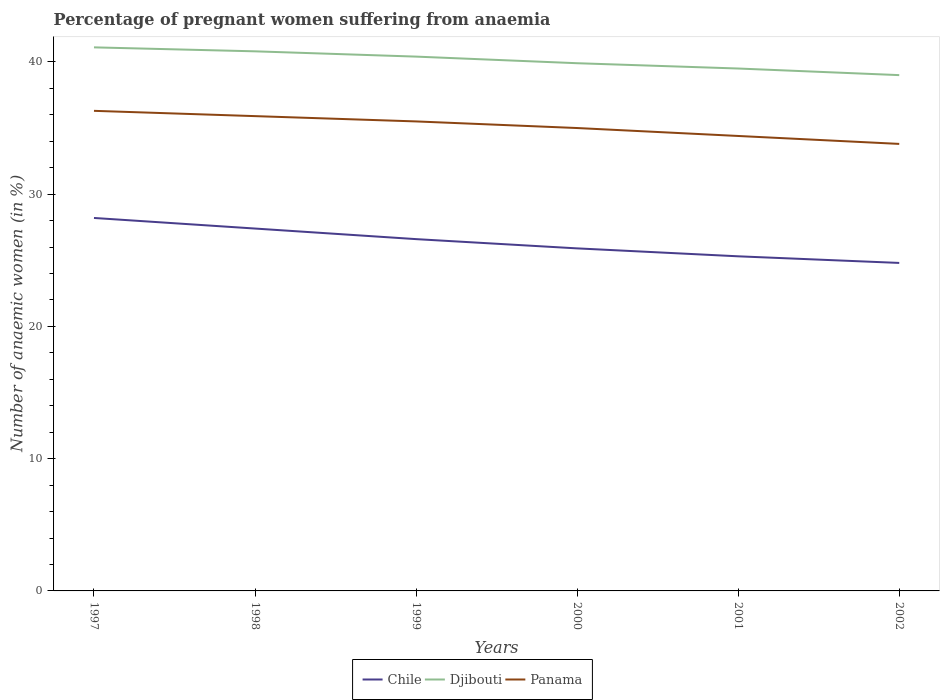How many different coloured lines are there?
Provide a short and direct response. 3. What is the difference between the highest and the second highest number of anaemic women in Djibouti?
Give a very brief answer. 2.1. How many lines are there?
Your answer should be very brief. 3. What is the difference between two consecutive major ticks on the Y-axis?
Provide a succinct answer. 10. Are the values on the major ticks of Y-axis written in scientific E-notation?
Your answer should be very brief. No. Does the graph contain any zero values?
Make the answer very short. No. Does the graph contain grids?
Offer a very short reply. No. Where does the legend appear in the graph?
Keep it short and to the point. Bottom center. How many legend labels are there?
Your response must be concise. 3. How are the legend labels stacked?
Give a very brief answer. Horizontal. What is the title of the graph?
Offer a terse response. Percentage of pregnant women suffering from anaemia. What is the label or title of the Y-axis?
Keep it short and to the point. Number of anaemic women (in %). What is the Number of anaemic women (in %) of Chile in 1997?
Your answer should be very brief. 28.2. What is the Number of anaemic women (in %) in Djibouti in 1997?
Your answer should be very brief. 41.1. What is the Number of anaemic women (in %) of Panama in 1997?
Keep it short and to the point. 36.3. What is the Number of anaemic women (in %) of Chile in 1998?
Your response must be concise. 27.4. What is the Number of anaemic women (in %) in Djibouti in 1998?
Provide a short and direct response. 40.8. What is the Number of anaemic women (in %) of Panama in 1998?
Make the answer very short. 35.9. What is the Number of anaemic women (in %) of Chile in 1999?
Your answer should be compact. 26.6. What is the Number of anaemic women (in %) of Djibouti in 1999?
Offer a terse response. 40.4. What is the Number of anaemic women (in %) of Panama in 1999?
Your answer should be compact. 35.5. What is the Number of anaemic women (in %) in Chile in 2000?
Your answer should be very brief. 25.9. What is the Number of anaemic women (in %) of Djibouti in 2000?
Offer a terse response. 39.9. What is the Number of anaemic women (in %) of Chile in 2001?
Your answer should be very brief. 25.3. What is the Number of anaemic women (in %) of Djibouti in 2001?
Make the answer very short. 39.5. What is the Number of anaemic women (in %) in Panama in 2001?
Give a very brief answer. 34.4. What is the Number of anaemic women (in %) in Chile in 2002?
Give a very brief answer. 24.8. What is the Number of anaemic women (in %) of Panama in 2002?
Your response must be concise. 33.8. Across all years, what is the maximum Number of anaemic women (in %) of Chile?
Provide a succinct answer. 28.2. Across all years, what is the maximum Number of anaemic women (in %) of Djibouti?
Your answer should be compact. 41.1. Across all years, what is the maximum Number of anaemic women (in %) of Panama?
Provide a succinct answer. 36.3. Across all years, what is the minimum Number of anaemic women (in %) of Chile?
Make the answer very short. 24.8. Across all years, what is the minimum Number of anaemic women (in %) in Panama?
Provide a succinct answer. 33.8. What is the total Number of anaemic women (in %) of Chile in the graph?
Provide a succinct answer. 158.2. What is the total Number of anaemic women (in %) in Djibouti in the graph?
Provide a succinct answer. 240.7. What is the total Number of anaemic women (in %) in Panama in the graph?
Provide a succinct answer. 210.9. What is the difference between the Number of anaemic women (in %) of Djibouti in 1997 and that in 1998?
Give a very brief answer. 0.3. What is the difference between the Number of anaemic women (in %) of Chile in 1997 and that in 1999?
Provide a succinct answer. 1.6. What is the difference between the Number of anaemic women (in %) of Djibouti in 1997 and that in 1999?
Ensure brevity in your answer.  0.7. What is the difference between the Number of anaemic women (in %) in Djibouti in 1997 and that in 2000?
Keep it short and to the point. 1.2. What is the difference between the Number of anaemic women (in %) of Panama in 1997 and that in 2000?
Give a very brief answer. 1.3. What is the difference between the Number of anaemic women (in %) of Chile in 1997 and that in 2001?
Offer a terse response. 2.9. What is the difference between the Number of anaemic women (in %) in Chile in 1997 and that in 2002?
Provide a short and direct response. 3.4. What is the difference between the Number of anaemic women (in %) of Panama in 1997 and that in 2002?
Provide a succinct answer. 2.5. What is the difference between the Number of anaemic women (in %) in Chile in 1998 and that in 1999?
Your response must be concise. 0.8. What is the difference between the Number of anaemic women (in %) in Djibouti in 1998 and that in 1999?
Offer a terse response. 0.4. What is the difference between the Number of anaemic women (in %) in Panama in 1998 and that in 1999?
Offer a terse response. 0.4. What is the difference between the Number of anaemic women (in %) in Djibouti in 1998 and that in 2000?
Ensure brevity in your answer.  0.9. What is the difference between the Number of anaemic women (in %) of Panama in 1998 and that in 2000?
Offer a very short reply. 0.9. What is the difference between the Number of anaemic women (in %) of Djibouti in 1998 and that in 2001?
Ensure brevity in your answer.  1.3. What is the difference between the Number of anaemic women (in %) of Chile in 1998 and that in 2002?
Offer a terse response. 2.6. What is the difference between the Number of anaemic women (in %) of Chile in 1999 and that in 2000?
Offer a terse response. 0.7. What is the difference between the Number of anaemic women (in %) of Djibouti in 1999 and that in 2000?
Provide a short and direct response. 0.5. What is the difference between the Number of anaemic women (in %) of Panama in 1999 and that in 2000?
Make the answer very short. 0.5. What is the difference between the Number of anaemic women (in %) in Djibouti in 1999 and that in 2001?
Offer a terse response. 0.9. What is the difference between the Number of anaemic women (in %) of Djibouti in 1999 and that in 2002?
Your answer should be very brief. 1.4. What is the difference between the Number of anaemic women (in %) of Panama in 1999 and that in 2002?
Keep it short and to the point. 1.7. What is the difference between the Number of anaemic women (in %) of Djibouti in 2000 and that in 2001?
Give a very brief answer. 0.4. What is the difference between the Number of anaemic women (in %) in Panama in 2000 and that in 2001?
Your answer should be very brief. 0.6. What is the difference between the Number of anaemic women (in %) in Panama in 2000 and that in 2002?
Give a very brief answer. 1.2. What is the difference between the Number of anaemic women (in %) in Chile in 2001 and that in 2002?
Provide a short and direct response. 0.5. What is the difference between the Number of anaemic women (in %) in Panama in 2001 and that in 2002?
Your answer should be very brief. 0.6. What is the difference between the Number of anaemic women (in %) of Chile in 1997 and the Number of anaemic women (in %) of Djibouti in 1998?
Keep it short and to the point. -12.6. What is the difference between the Number of anaemic women (in %) of Chile in 1997 and the Number of anaemic women (in %) of Djibouti in 2000?
Your response must be concise. -11.7. What is the difference between the Number of anaemic women (in %) of Chile in 1997 and the Number of anaemic women (in %) of Djibouti in 2001?
Provide a succinct answer. -11.3. What is the difference between the Number of anaemic women (in %) in Chile in 1997 and the Number of anaemic women (in %) in Panama in 2001?
Make the answer very short. -6.2. What is the difference between the Number of anaemic women (in %) of Chile in 1997 and the Number of anaemic women (in %) of Panama in 2002?
Ensure brevity in your answer.  -5.6. What is the difference between the Number of anaemic women (in %) of Chile in 1998 and the Number of anaemic women (in %) of Panama in 1999?
Give a very brief answer. -8.1. What is the difference between the Number of anaemic women (in %) in Chile in 1998 and the Number of anaemic women (in %) in Djibouti in 2000?
Your answer should be compact. -12.5. What is the difference between the Number of anaemic women (in %) in Chile in 1998 and the Number of anaemic women (in %) in Panama in 2000?
Your response must be concise. -7.6. What is the difference between the Number of anaemic women (in %) in Chile in 1998 and the Number of anaemic women (in %) in Panama in 2001?
Your answer should be very brief. -7. What is the difference between the Number of anaemic women (in %) of Djibouti in 1998 and the Number of anaemic women (in %) of Panama in 2001?
Provide a short and direct response. 6.4. What is the difference between the Number of anaemic women (in %) of Chile in 1999 and the Number of anaemic women (in %) of Djibouti in 2000?
Provide a short and direct response. -13.3. What is the difference between the Number of anaemic women (in %) in Chile in 1999 and the Number of anaemic women (in %) in Panama in 2000?
Your response must be concise. -8.4. What is the difference between the Number of anaemic women (in %) in Chile in 1999 and the Number of anaemic women (in %) in Djibouti in 2001?
Provide a short and direct response. -12.9. What is the difference between the Number of anaemic women (in %) of Chile in 1999 and the Number of anaemic women (in %) of Panama in 2001?
Ensure brevity in your answer.  -7.8. What is the difference between the Number of anaemic women (in %) of Djibouti in 1999 and the Number of anaemic women (in %) of Panama in 2001?
Offer a terse response. 6. What is the difference between the Number of anaemic women (in %) in Chile in 1999 and the Number of anaemic women (in %) in Djibouti in 2002?
Keep it short and to the point. -12.4. What is the difference between the Number of anaemic women (in %) in Chile in 1999 and the Number of anaemic women (in %) in Panama in 2002?
Offer a very short reply. -7.2. What is the difference between the Number of anaemic women (in %) in Djibouti in 1999 and the Number of anaemic women (in %) in Panama in 2002?
Provide a succinct answer. 6.6. What is the difference between the Number of anaemic women (in %) of Chile in 2000 and the Number of anaemic women (in %) of Djibouti in 2001?
Your response must be concise. -13.6. What is the difference between the Number of anaemic women (in %) in Chile in 2000 and the Number of anaemic women (in %) in Panama in 2001?
Ensure brevity in your answer.  -8.5. What is the difference between the Number of anaemic women (in %) in Chile in 2000 and the Number of anaemic women (in %) in Djibouti in 2002?
Provide a short and direct response. -13.1. What is the difference between the Number of anaemic women (in %) in Chile in 2000 and the Number of anaemic women (in %) in Panama in 2002?
Ensure brevity in your answer.  -7.9. What is the difference between the Number of anaemic women (in %) of Chile in 2001 and the Number of anaemic women (in %) of Djibouti in 2002?
Provide a succinct answer. -13.7. What is the average Number of anaemic women (in %) in Chile per year?
Your response must be concise. 26.37. What is the average Number of anaemic women (in %) in Djibouti per year?
Keep it short and to the point. 40.12. What is the average Number of anaemic women (in %) in Panama per year?
Provide a succinct answer. 35.15. In the year 1998, what is the difference between the Number of anaemic women (in %) in Chile and Number of anaemic women (in %) in Djibouti?
Ensure brevity in your answer.  -13.4. In the year 1998, what is the difference between the Number of anaemic women (in %) of Chile and Number of anaemic women (in %) of Panama?
Offer a terse response. -8.5. In the year 1998, what is the difference between the Number of anaemic women (in %) in Djibouti and Number of anaemic women (in %) in Panama?
Your answer should be very brief. 4.9. In the year 1999, what is the difference between the Number of anaemic women (in %) of Chile and Number of anaemic women (in %) of Djibouti?
Provide a short and direct response. -13.8. In the year 1999, what is the difference between the Number of anaemic women (in %) in Chile and Number of anaemic women (in %) in Panama?
Keep it short and to the point. -8.9. In the year 2001, what is the difference between the Number of anaemic women (in %) in Chile and Number of anaemic women (in %) in Djibouti?
Offer a very short reply. -14.2. In the year 2001, what is the difference between the Number of anaemic women (in %) of Chile and Number of anaemic women (in %) of Panama?
Your response must be concise. -9.1. In the year 2001, what is the difference between the Number of anaemic women (in %) in Djibouti and Number of anaemic women (in %) in Panama?
Offer a terse response. 5.1. In the year 2002, what is the difference between the Number of anaemic women (in %) in Chile and Number of anaemic women (in %) in Djibouti?
Offer a terse response. -14.2. In the year 2002, what is the difference between the Number of anaemic women (in %) in Djibouti and Number of anaemic women (in %) in Panama?
Offer a very short reply. 5.2. What is the ratio of the Number of anaemic women (in %) in Chile in 1997 to that in 1998?
Your answer should be very brief. 1.03. What is the ratio of the Number of anaemic women (in %) in Djibouti in 1997 to that in 1998?
Your response must be concise. 1.01. What is the ratio of the Number of anaemic women (in %) of Panama in 1997 to that in 1998?
Offer a very short reply. 1.01. What is the ratio of the Number of anaemic women (in %) in Chile in 1997 to that in 1999?
Give a very brief answer. 1.06. What is the ratio of the Number of anaemic women (in %) in Djibouti in 1997 to that in 1999?
Keep it short and to the point. 1.02. What is the ratio of the Number of anaemic women (in %) in Panama in 1997 to that in 1999?
Provide a succinct answer. 1.02. What is the ratio of the Number of anaemic women (in %) of Chile in 1997 to that in 2000?
Your answer should be compact. 1.09. What is the ratio of the Number of anaemic women (in %) in Djibouti in 1997 to that in 2000?
Make the answer very short. 1.03. What is the ratio of the Number of anaemic women (in %) of Panama in 1997 to that in 2000?
Your answer should be compact. 1.04. What is the ratio of the Number of anaemic women (in %) of Chile in 1997 to that in 2001?
Offer a terse response. 1.11. What is the ratio of the Number of anaemic women (in %) in Djibouti in 1997 to that in 2001?
Give a very brief answer. 1.04. What is the ratio of the Number of anaemic women (in %) of Panama in 1997 to that in 2001?
Offer a terse response. 1.06. What is the ratio of the Number of anaemic women (in %) in Chile in 1997 to that in 2002?
Offer a very short reply. 1.14. What is the ratio of the Number of anaemic women (in %) of Djibouti in 1997 to that in 2002?
Your response must be concise. 1.05. What is the ratio of the Number of anaemic women (in %) in Panama in 1997 to that in 2002?
Provide a succinct answer. 1.07. What is the ratio of the Number of anaemic women (in %) of Chile in 1998 to that in 1999?
Give a very brief answer. 1.03. What is the ratio of the Number of anaemic women (in %) in Djibouti in 1998 to that in 1999?
Make the answer very short. 1.01. What is the ratio of the Number of anaemic women (in %) of Panama in 1998 to that in 1999?
Your answer should be compact. 1.01. What is the ratio of the Number of anaemic women (in %) in Chile in 1998 to that in 2000?
Your answer should be compact. 1.06. What is the ratio of the Number of anaemic women (in %) in Djibouti in 1998 to that in 2000?
Keep it short and to the point. 1.02. What is the ratio of the Number of anaemic women (in %) in Panama in 1998 to that in 2000?
Keep it short and to the point. 1.03. What is the ratio of the Number of anaemic women (in %) of Chile in 1998 to that in 2001?
Keep it short and to the point. 1.08. What is the ratio of the Number of anaemic women (in %) in Djibouti in 1998 to that in 2001?
Offer a terse response. 1.03. What is the ratio of the Number of anaemic women (in %) in Panama in 1998 to that in 2001?
Your answer should be very brief. 1.04. What is the ratio of the Number of anaemic women (in %) of Chile in 1998 to that in 2002?
Provide a succinct answer. 1.1. What is the ratio of the Number of anaemic women (in %) of Djibouti in 1998 to that in 2002?
Make the answer very short. 1.05. What is the ratio of the Number of anaemic women (in %) in Panama in 1998 to that in 2002?
Keep it short and to the point. 1.06. What is the ratio of the Number of anaemic women (in %) in Djibouti in 1999 to that in 2000?
Keep it short and to the point. 1.01. What is the ratio of the Number of anaemic women (in %) in Panama in 1999 to that in 2000?
Make the answer very short. 1.01. What is the ratio of the Number of anaemic women (in %) of Chile in 1999 to that in 2001?
Make the answer very short. 1.05. What is the ratio of the Number of anaemic women (in %) in Djibouti in 1999 to that in 2001?
Provide a succinct answer. 1.02. What is the ratio of the Number of anaemic women (in %) in Panama in 1999 to that in 2001?
Offer a terse response. 1.03. What is the ratio of the Number of anaemic women (in %) of Chile in 1999 to that in 2002?
Give a very brief answer. 1.07. What is the ratio of the Number of anaemic women (in %) in Djibouti in 1999 to that in 2002?
Keep it short and to the point. 1.04. What is the ratio of the Number of anaemic women (in %) of Panama in 1999 to that in 2002?
Your answer should be compact. 1.05. What is the ratio of the Number of anaemic women (in %) in Chile in 2000 to that in 2001?
Offer a very short reply. 1.02. What is the ratio of the Number of anaemic women (in %) of Djibouti in 2000 to that in 2001?
Provide a succinct answer. 1.01. What is the ratio of the Number of anaemic women (in %) of Panama in 2000 to that in 2001?
Keep it short and to the point. 1.02. What is the ratio of the Number of anaemic women (in %) in Chile in 2000 to that in 2002?
Your response must be concise. 1.04. What is the ratio of the Number of anaemic women (in %) in Djibouti in 2000 to that in 2002?
Your response must be concise. 1.02. What is the ratio of the Number of anaemic women (in %) of Panama in 2000 to that in 2002?
Make the answer very short. 1.04. What is the ratio of the Number of anaemic women (in %) of Chile in 2001 to that in 2002?
Keep it short and to the point. 1.02. What is the ratio of the Number of anaemic women (in %) of Djibouti in 2001 to that in 2002?
Keep it short and to the point. 1.01. What is the ratio of the Number of anaemic women (in %) of Panama in 2001 to that in 2002?
Offer a terse response. 1.02. What is the difference between the highest and the second highest Number of anaemic women (in %) in Djibouti?
Your response must be concise. 0.3. What is the difference between the highest and the second highest Number of anaemic women (in %) of Panama?
Your response must be concise. 0.4. What is the difference between the highest and the lowest Number of anaemic women (in %) of Panama?
Provide a succinct answer. 2.5. 